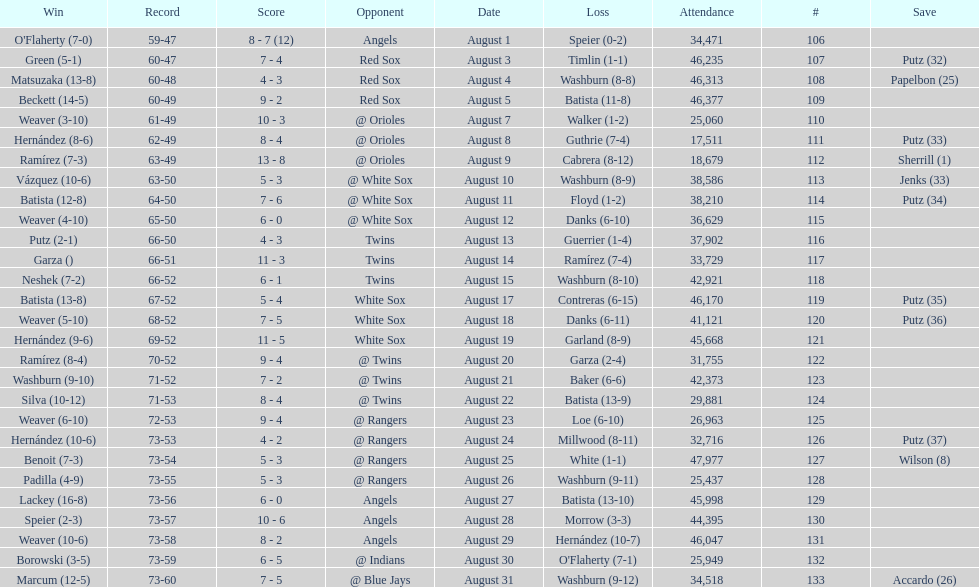What was the total number of games played in august 2007? 28. 